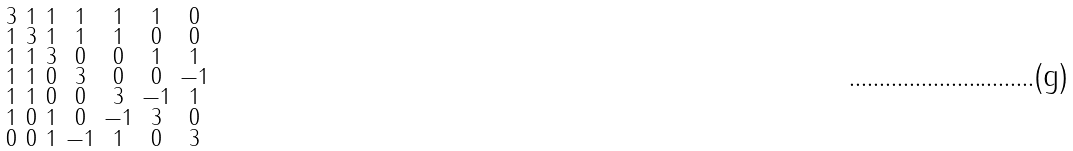<formula> <loc_0><loc_0><loc_500><loc_500>\begin{smallmatrix} 3 & 1 & 1 & 1 & 1 & 1 & 0 \\ 1 & 3 & 1 & 1 & 1 & 0 & 0 \\ 1 & 1 & 3 & 0 & 0 & 1 & 1 \\ 1 & 1 & 0 & 3 & 0 & 0 & - 1 \\ 1 & 1 & 0 & 0 & 3 & - 1 & 1 \\ 1 & 0 & 1 & 0 & - 1 & 3 & 0 \\ 0 & 0 & 1 & - 1 & 1 & 0 & 3 \end{smallmatrix}</formula> 